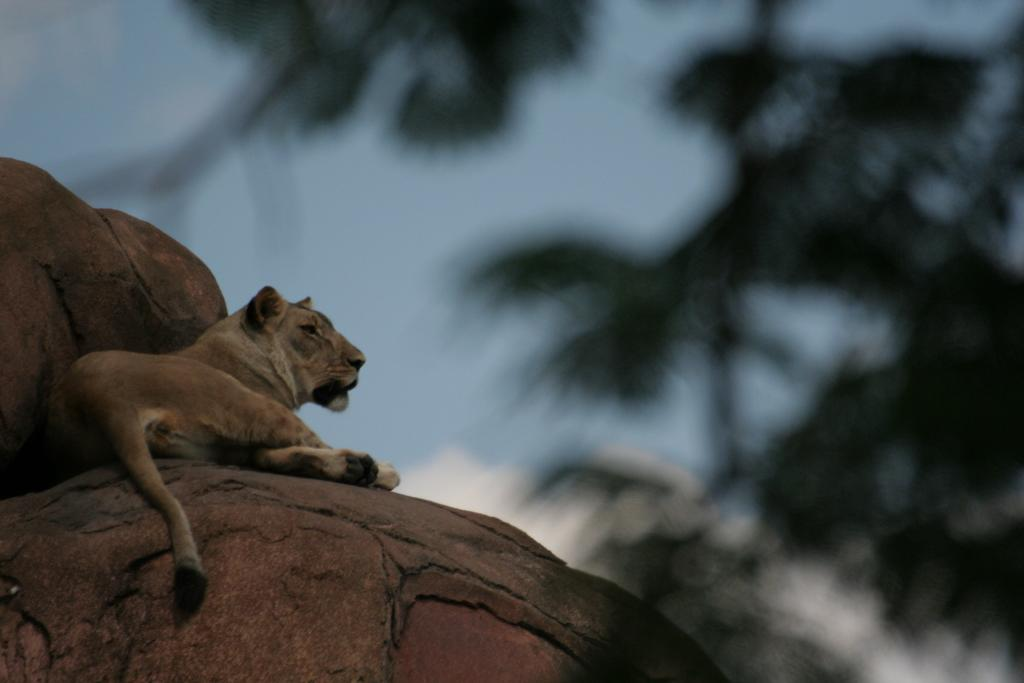What animal is present in the image? There is a lion in the image. What type of terrain can be seen in the image? There are rocks in the image. What can be seen in the distance in the image? The sky is visible in the background of the image. How would you describe the focus of the image? The background of the image appears blurry. What is the lion's opinion on the concept of hate in the image? The image does not depict the lion's thoughts or opinions, so it is not possible to determine its stance on the concept of hate. 